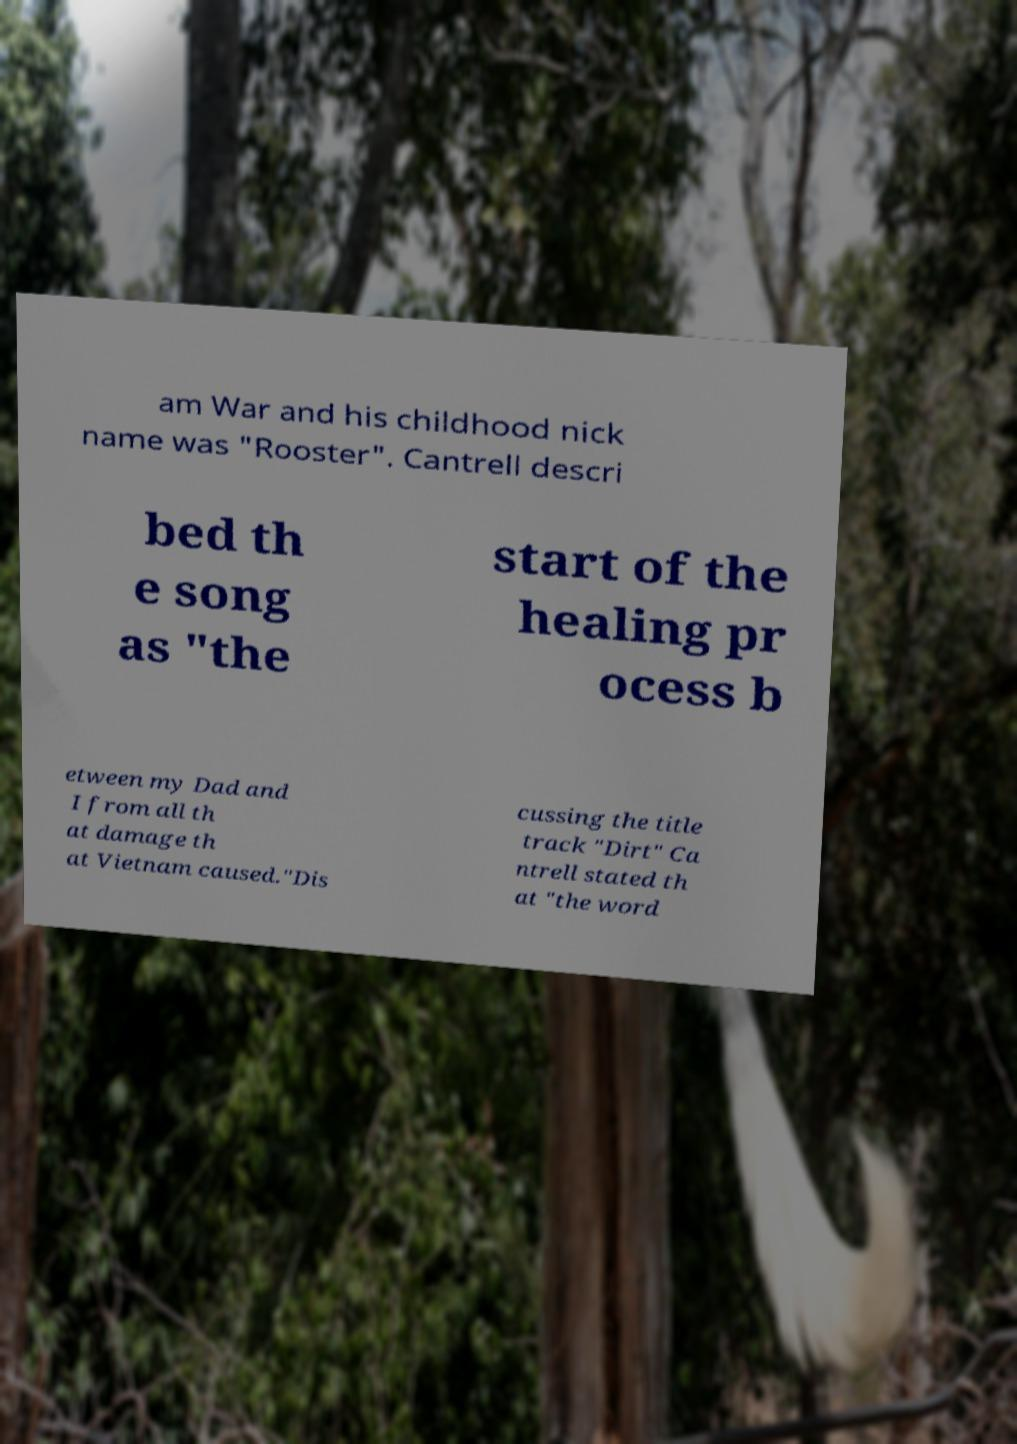Can you read and provide the text displayed in the image?This photo seems to have some interesting text. Can you extract and type it out for me? am War and his childhood nick name was "Rooster". Cantrell descri bed th e song as "the start of the healing pr ocess b etween my Dad and I from all th at damage th at Vietnam caused."Dis cussing the title track "Dirt" Ca ntrell stated th at "the word 